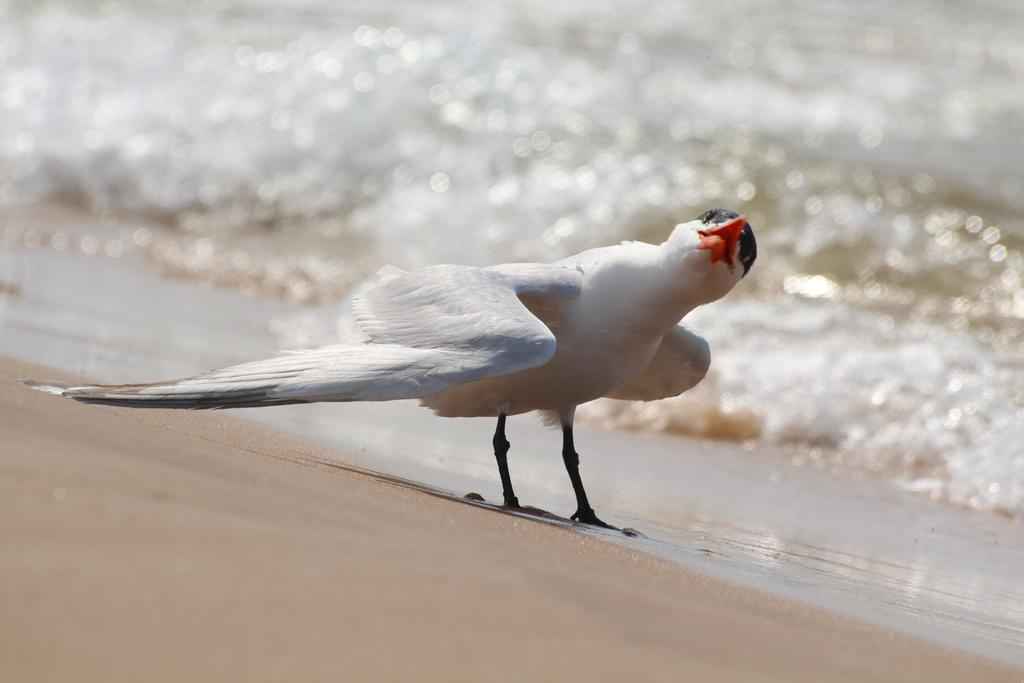What is the main subject of the image? There is a bird in the center of the image. What is the bird doing in the image? The bird is standing on the ground. What can be seen in the background of the image? There is water visible in the background of the image. What type of monkey can be seen falling from a tree in the image? There is no monkey or tree present in the image; it features a bird standing on the ground with water visible in the background. 